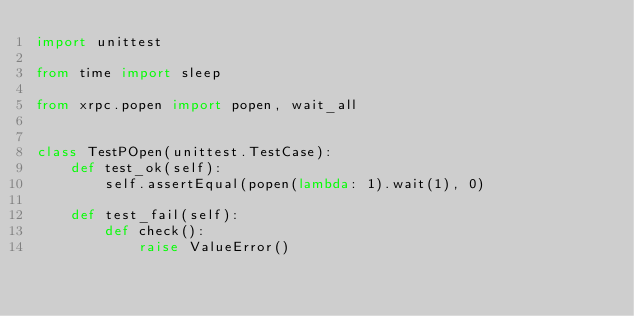Convert code to text. <code><loc_0><loc_0><loc_500><loc_500><_Python_>import unittest

from time import sleep

from xrpc.popen import popen, wait_all


class TestPOpen(unittest.TestCase):
    def test_ok(self):
        self.assertEqual(popen(lambda: 1).wait(1), 0)

    def test_fail(self):
        def check():
            raise ValueError()
</code> 